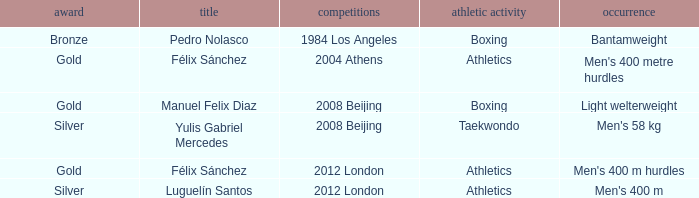Which Medal had a Games of 2008 beijing, and a Sport of taekwondo? Silver. 